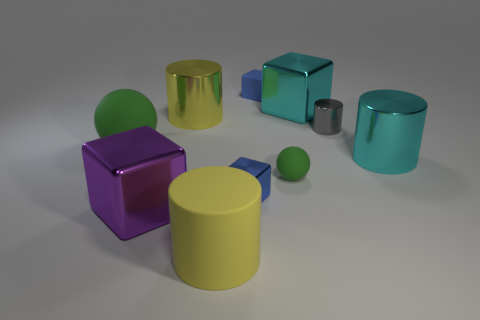If this image represented a scene from a story, what could that story be about? If interpreted as a scene from a story, this image might depict a moment in a whimsical land where geometric shapes come to life. Perhaps it’s a tale about a group of friends who are shapes with distinct personalities, embarking on a journey to find a missing companion. The green sphere might be the wise leader, the yellow cylinder the cheerful sidekick, and the purple cube, although apart, could be the ingenious inventor of the group. 